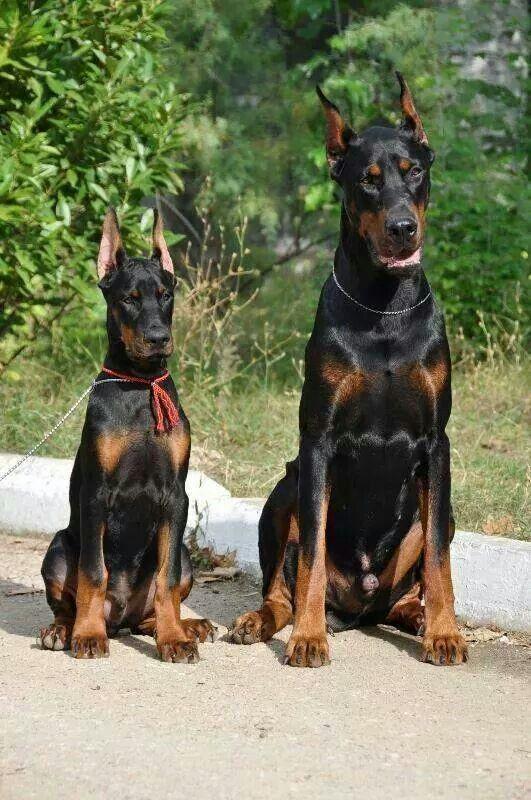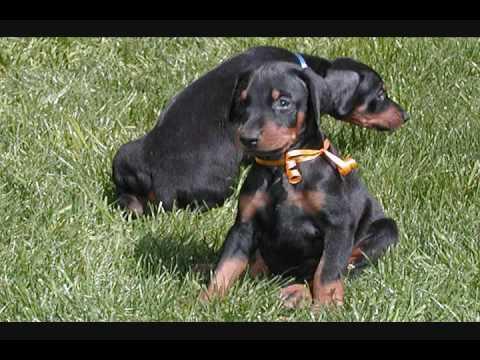The first image is the image on the left, the second image is the image on the right. Examine the images to the left and right. Is the description "The left image includes side-by-side, identically-posed, forward-facing dobermans with erect pointy ears, and the right image contains two dobermans with floppy ears." accurate? Answer yes or no. Yes. The first image is the image on the left, the second image is the image on the right. Given the left and right images, does the statement "A darker colored dog is lying next to a lighter colored one of the same breed in at least one image." hold true? Answer yes or no. No. 